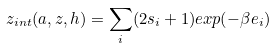Convert formula to latex. <formula><loc_0><loc_0><loc_500><loc_500>z _ { i n t } ( a , z , h ) = \sum _ { i } ( 2 s _ { i } + 1 ) e x p ( - \beta e _ { i } )</formula> 